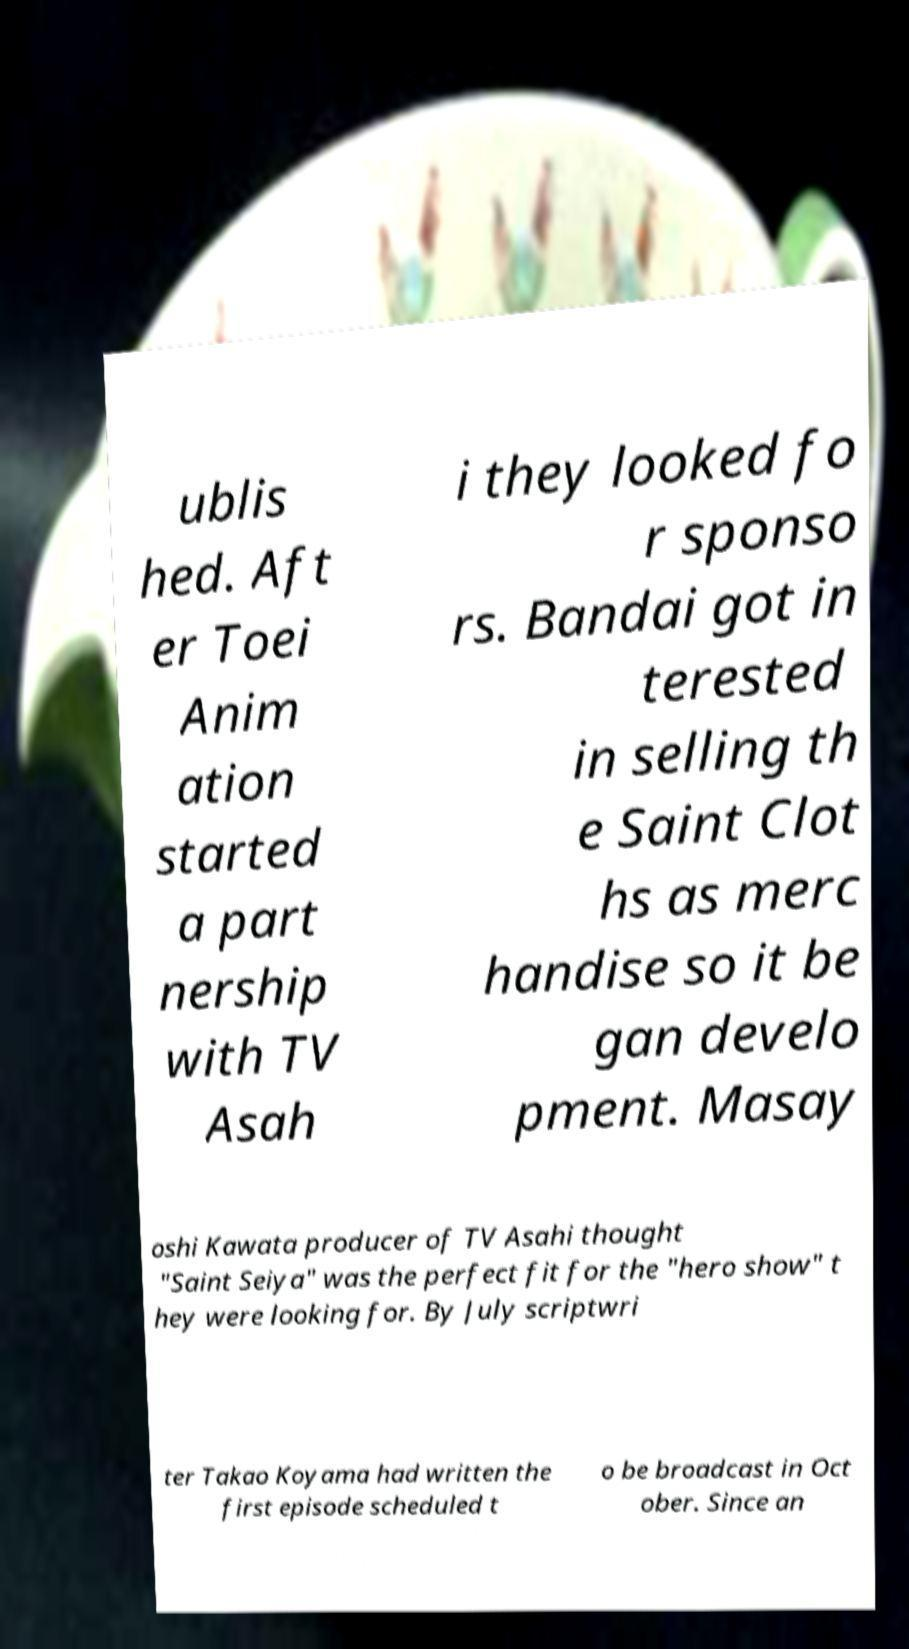Can you read and provide the text displayed in the image?This photo seems to have some interesting text. Can you extract and type it out for me? ublis hed. Aft er Toei Anim ation started a part nership with TV Asah i they looked fo r sponso rs. Bandai got in terested in selling th e Saint Clot hs as merc handise so it be gan develo pment. Masay oshi Kawata producer of TV Asahi thought "Saint Seiya" was the perfect fit for the "hero show" t hey were looking for. By July scriptwri ter Takao Koyama had written the first episode scheduled t o be broadcast in Oct ober. Since an 